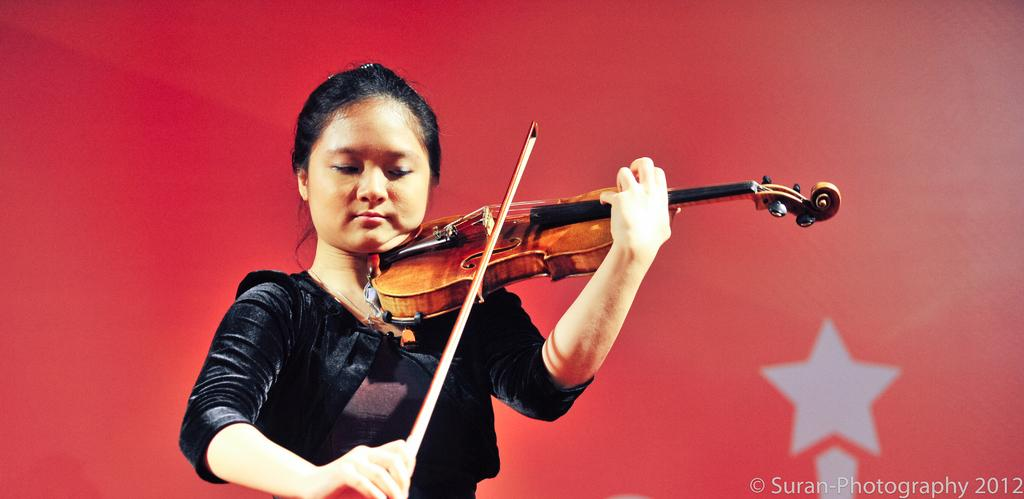What is the main subject of the image? The main subject of the image is a woman. What is the woman doing in the image? The woman is playing a violin in the image. What color is the background of the image? The background of the image is red. What type of holiday is the woman celebrating in the image? There is no indication of a holiday in the image; it simply shows a woman playing a violin with a red background. 